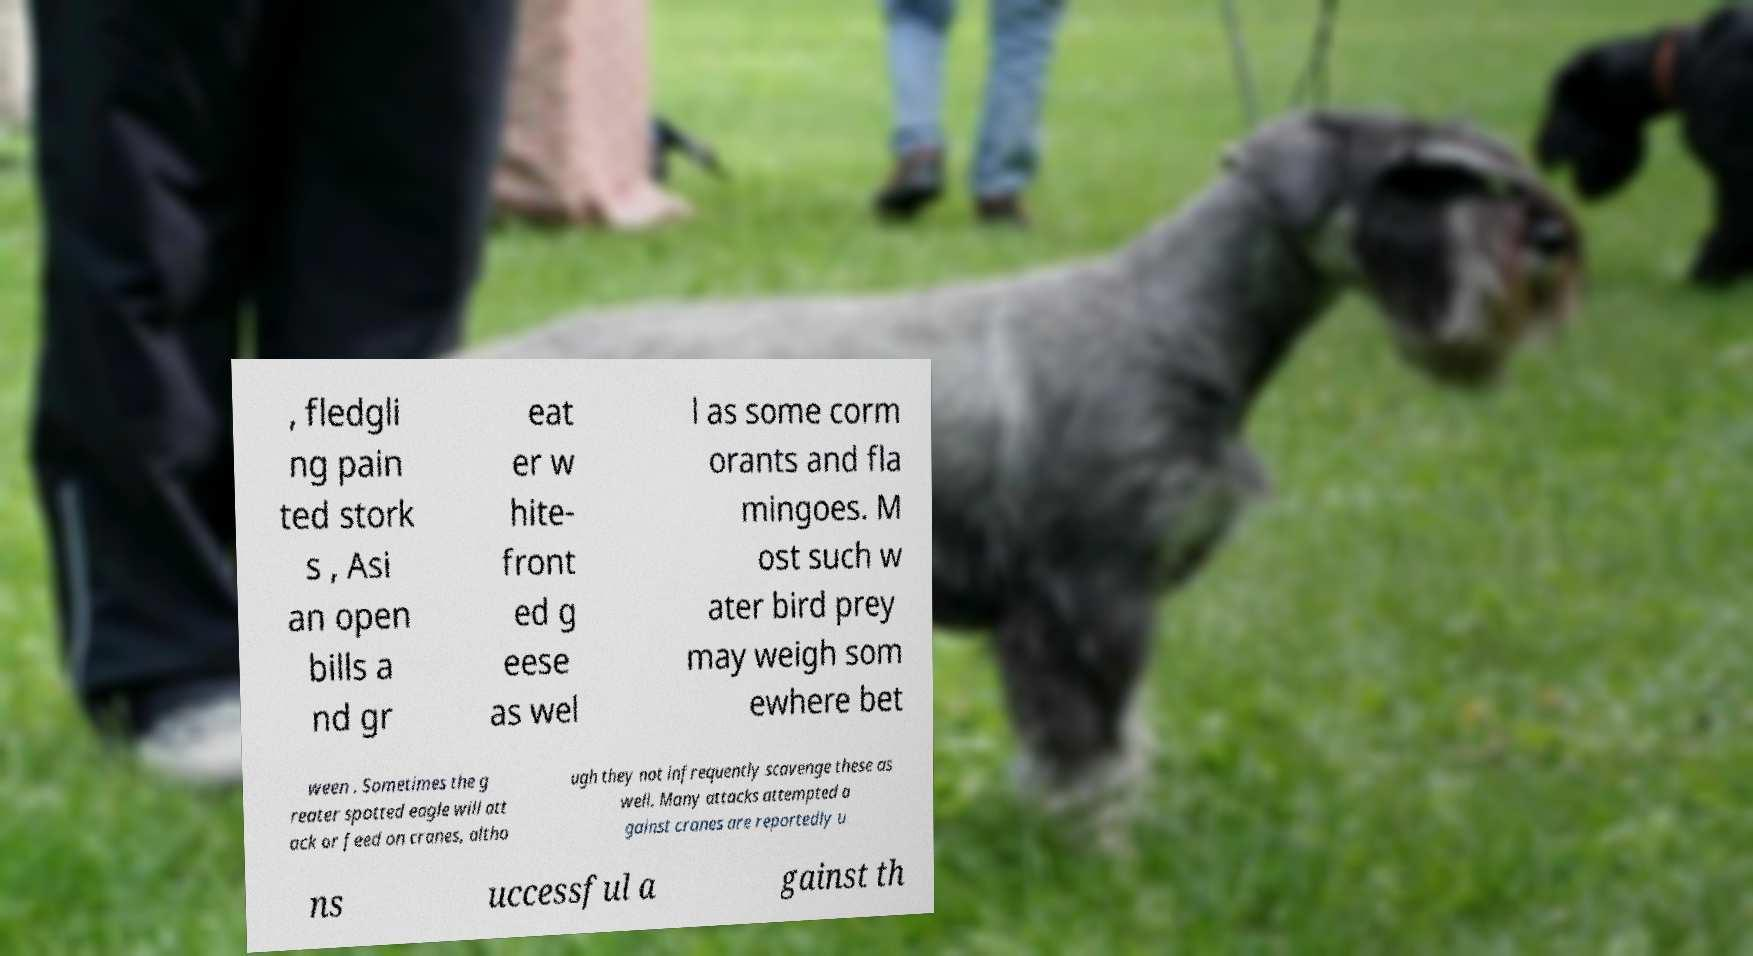Please identify and transcribe the text found in this image. , fledgli ng pain ted stork s , Asi an open bills a nd gr eat er w hite- front ed g eese as wel l as some corm orants and fla mingoes. M ost such w ater bird prey may weigh som ewhere bet ween . Sometimes the g reater spotted eagle will att ack or feed on cranes, altho ugh they not infrequently scavenge these as well. Many attacks attempted a gainst cranes are reportedly u ns uccessful a gainst th 